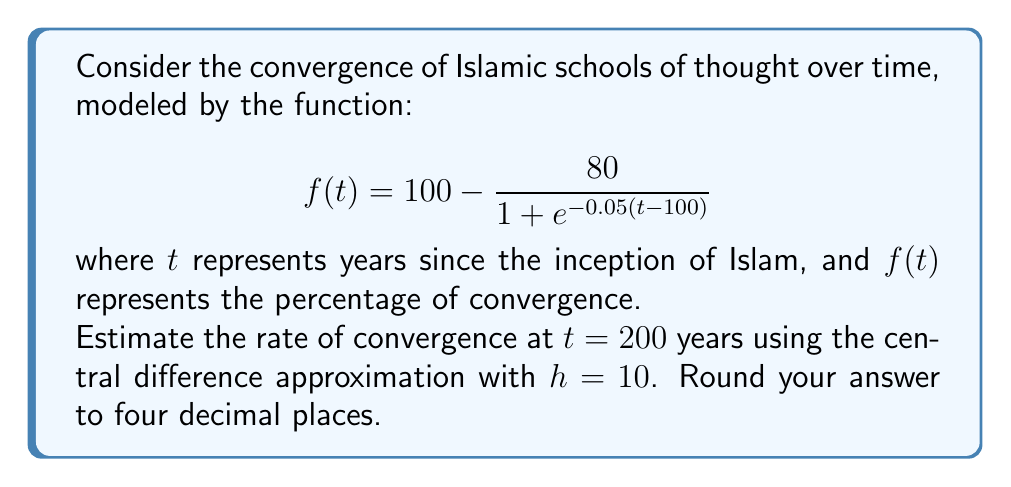Can you solve this math problem? To estimate the rate of convergence at $t = 200$ using the central difference approximation, we'll follow these steps:

1) The central difference formula for the derivative is:

   $$f'(t) \approx \frac{f(t+h) - f(t-h)}{2h}$$

2) We need to calculate $f(190)$ and $f(210)$:

   For $t = 190$:
   $$f(190) = 100 - \frac{80}{1 + e^{-0.05(190-100)}} = 100 - \frac{80}{1 + e^{-4.5}} = 34.2724$$

   For $t = 210$:
   $$f(210) = 100 - \frac{80}{1 + e^{-0.05(210-100)}} = 100 - \frac{80}{1 + e^{-5.5}} = 39.5242$$

3) Now we can apply the central difference formula:

   $$f'(200) \approx \frac{f(210) - f(190)}{2(10)} = \frac{39.5242 - 34.2724}{20} = 0.2626$$

4) Rounding to four decimal places:

   $$f'(200) \approx 0.2626$$

This result represents the estimated rate of convergence at 200 years, measured in percentage points per year.
Answer: 0.2626 